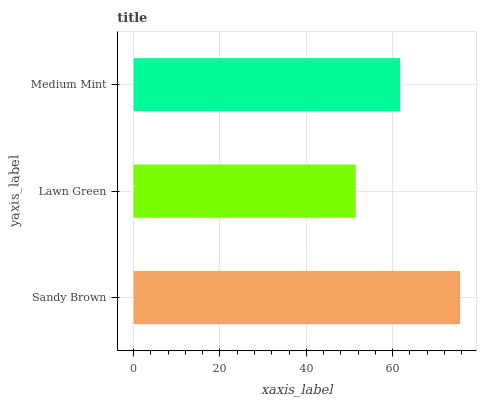Is Lawn Green the minimum?
Answer yes or no. Yes. Is Sandy Brown the maximum?
Answer yes or no. Yes. Is Medium Mint the minimum?
Answer yes or no. No. Is Medium Mint the maximum?
Answer yes or no. No. Is Medium Mint greater than Lawn Green?
Answer yes or no. Yes. Is Lawn Green less than Medium Mint?
Answer yes or no. Yes. Is Lawn Green greater than Medium Mint?
Answer yes or no. No. Is Medium Mint less than Lawn Green?
Answer yes or no. No. Is Medium Mint the high median?
Answer yes or no. Yes. Is Medium Mint the low median?
Answer yes or no. Yes. Is Sandy Brown the high median?
Answer yes or no. No. Is Lawn Green the low median?
Answer yes or no. No. 